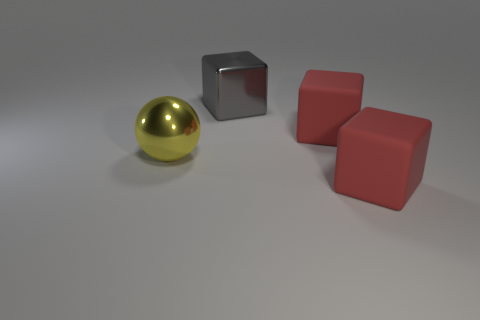Do the large sphere and the metallic object on the right side of the yellow shiny ball have the same color?
Offer a very short reply. No. How many other things are the same material as the ball?
Your answer should be very brief. 1. There is a large thing that is the same material as the big gray block; what shape is it?
Your response must be concise. Sphere. Is there anything else that is the same color as the large sphere?
Give a very brief answer. No. Is the number of gray metallic cubes to the left of the large yellow shiny thing greater than the number of big red matte cubes?
Provide a succinct answer. No. There is a big yellow shiny object; is its shape the same as the gray object behind the yellow sphere?
Your response must be concise. No. What number of red matte cubes are the same size as the gray metal object?
Make the answer very short. 2. There is a red rubber block left of the red matte thing that is in front of the ball; how many big red blocks are on the right side of it?
Provide a succinct answer. 1. Is the number of large gray blocks left of the yellow ball the same as the number of red things that are on the left side of the large gray cube?
Provide a short and direct response. Yes. How many red matte things have the same shape as the big gray thing?
Ensure brevity in your answer.  2. 